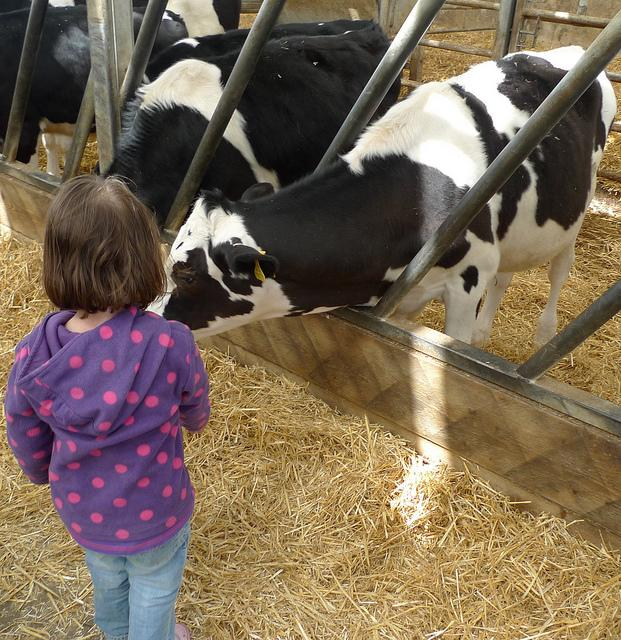What design is on the little girl's hoodie? polka dots 